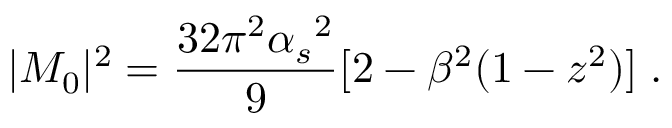Convert formula to latex. <formula><loc_0><loc_0><loc_500><loc_500>| M _ { 0 } | ^ { 2 } = \frac { 3 2 \pi ^ { 2 } { \alpha _ { s } } ^ { 2 } } { 9 } [ 2 - \beta ^ { 2 } ( 1 - z ^ { 2 } ) ] \, .</formula> 